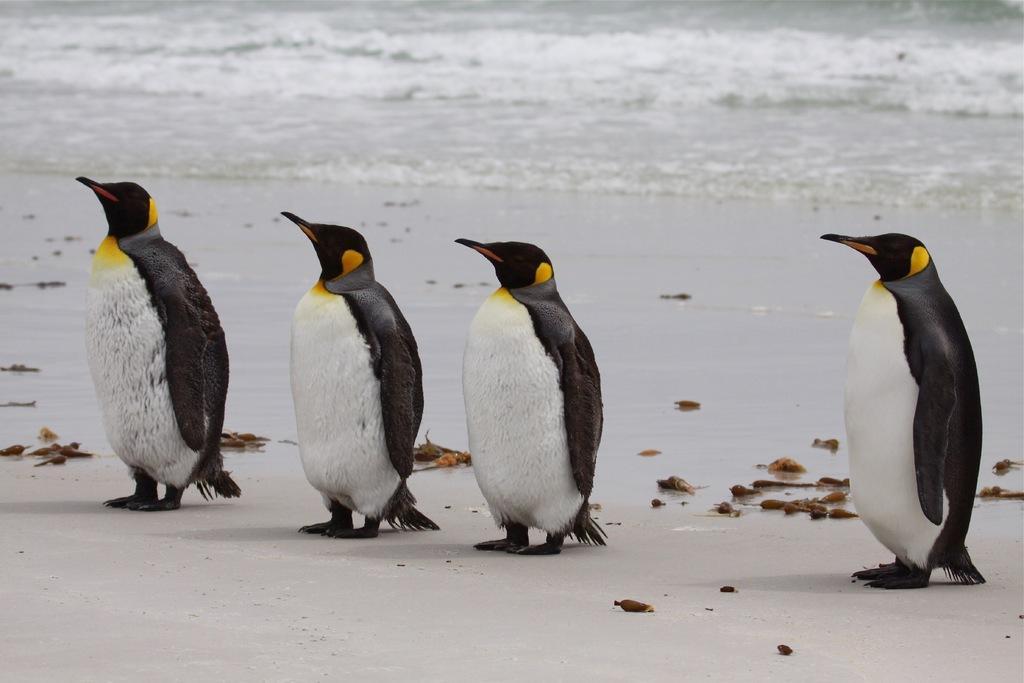Can you describe this image briefly? In this image there are four penguins standing on the seashore, and in the background there is water. 